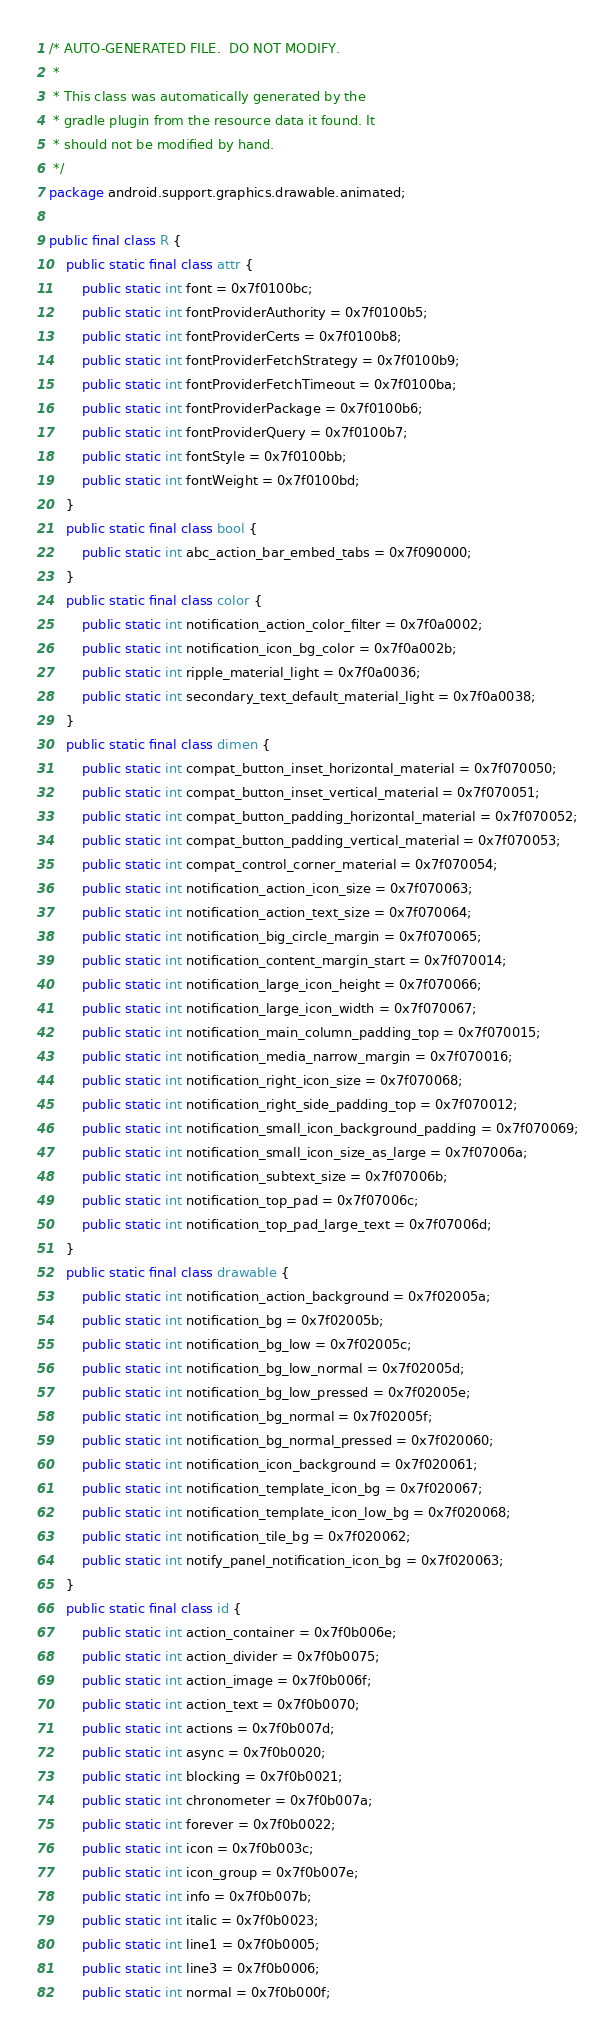<code> <loc_0><loc_0><loc_500><loc_500><_Java_>/* AUTO-GENERATED FILE.  DO NOT MODIFY.
 *
 * This class was automatically generated by the
 * gradle plugin from the resource data it found. It
 * should not be modified by hand.
 */
package android.support.graphics.drawable.animated;

public final class R {
    public static final class attr {
        public static int font = 0x7f0100bc;
        public static int fontProviderAuthority = 0x7f0100b5;
        public static int fontProviderCerts = 0x7f0100b8;
        public static int fontProviderFetchStrategy = 0x7f0100b9;
        public static int fontProviderFetchTimeout = 0x7f0100ba;
        public static int fontProviderPackage = 0x7f0100b6;
        public static int fontProviderQuery = 0x7f0100b7;
        public static int fontStyle = 0x7f0100bb;
        public static int fontWeight = 0x7f0100bd;
    }
    public static final class bool {
        public static int abc_action_bar_embed_tabs = 0x7f090000;
    }
    public static final class color {
        public static int notification_action_color_filter = 0x7f0a0002;
        public static int notification_icon_bg_color = 0x7f0a002b;
        public static int ripple_material_light = 0x7f0a0036;
        public static int secondary_text_default_material_light = 0x7f0a0038;
    }
    public static final class dimen {
        public static int compat_button_inset_horizontal_material = 0x7f070050;
        public static int compat_button_inset_vertical_material = 0x7f070051;
        public static int compat_button_padding_horizontal_material = 0x7f070052;
        public static int compat_button_padding_vertical_material = 0x7f070053;
        public static int compat_control_corner_material = 0x7f070054;
        public static int notification_action_icon_size = 0x7f070063;
        public static int notification_action_text_size = 0x7f070064;
        public static int notification_big_circle_margin = 0x7f070065;
        public static int notification_content_margin_start = 0x7f070014;
        public static int notification_large_icon_height = 0x7f070066;
        public static int notification_large_icon_width = 0x7f070067;
        public static int notification_main_column_padding_top = 0x7f070015;
        public static int notification_media_narrow_margin = 0x7f070016;
        public static int notification_right_icon_size = 0x7f070068;
        public static int notification_right_side_padding_top = 0x7f070012;
        public static int notification_small_icon_background_padding = 0x7f070069;
        public static int notification_small_icon_size_as_large = 0x7f07006a;
        public static int notification_subtext_size = 0x7f07006b;
        public static int notification_top_pad = 0x7f07006c;
        public static int notification_top_pad_large_text = 0x7f07006d;
    }
    public static final class drawable {
        public static int notification_action_background = 0x7f02005a;
        public static int notification_bg = 0x7f02005b;
        public static int notification_bg_low = 0x7f02005c;
        public static int notification_bg_low_normal = 0x7f02005d;
        public static int notification_bg_low_pressed = 0x7f02005e;
        public static int notification_bg_normal = 0x7f02005f;
        public static int notification_bg_normal_pressed = 0x7f020060;
        public static int notification_icon_background = 0x7f020061;
        public static int notification_template_icon_bg = 0x7f020067;
        public static int notification_template_icon_low_bg = 0x7f020068;
        public static int notification_tile_bg = 0x7f020062;
        public static int notify_panel_notification_icon_bg = 0x7f020063;
    }
    public static final class id {
        public static int action_container = 0x7f0b006e;
        public static int action_divider = 0x7f0b0075;
        public static int action_image = 0x7f0b006f;
        public static int action_text = 0x7f0b0070;
        public static int actions = 0x7f0b007d;
        public static int async = 0x7f0b0020;
        public static int blocking = 0x7f0b0021;
        public static int chronometer = 0x7f0b007a;
        public static int forever = 0x7f0b0022;
        public static int icon = 0x7f0b003c;
        public static int icon_group = 0x7f0b007e;
        public static int info = 0x7f0b007b;
        public static int italic = 0x7f0b0023;
        public static int line1 = 0x7f0b0005;
        public static int line3 = 0x7f0b0006;
        public static int normal = 0x7f0b000f;</code> 